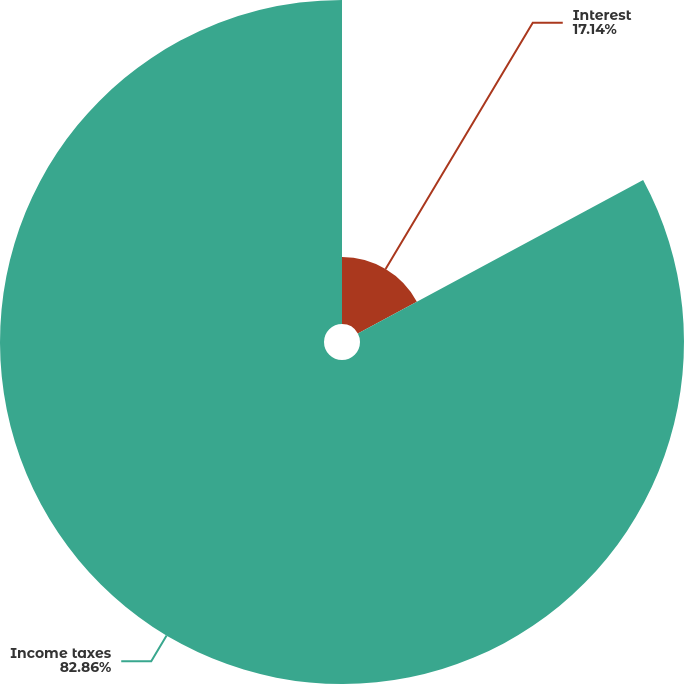Convert chart to OTSL. <chart><loc_0><loc_0><loc_500><loc_500><pie_chart><fcel>Interest<fcel>Income taxes<nl><fcel>17.14%<fcel>82.86%<nl></chart> 